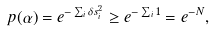<formula> <loc_0><loc_0><loc_500><loc_500>p ( \alpha ) = e ^ { - \sum _ { i } \delta s _ { i } ^ { 2 } } \geq e ^ { - \sum _ { i } 1 } = e ^ { - N } ,</formula> 